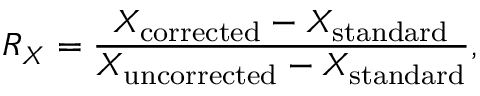Convert formula to latex. <formula><loc_0><loc_0><loc_500><loc_500>R _ { X } = \frac { X _ { c o r r e c t e d } - X _ { s t a n d a r d } } { X _ { u n c o r r e c t e d } - X _ { s t a n d a r d } } ,</formula> 